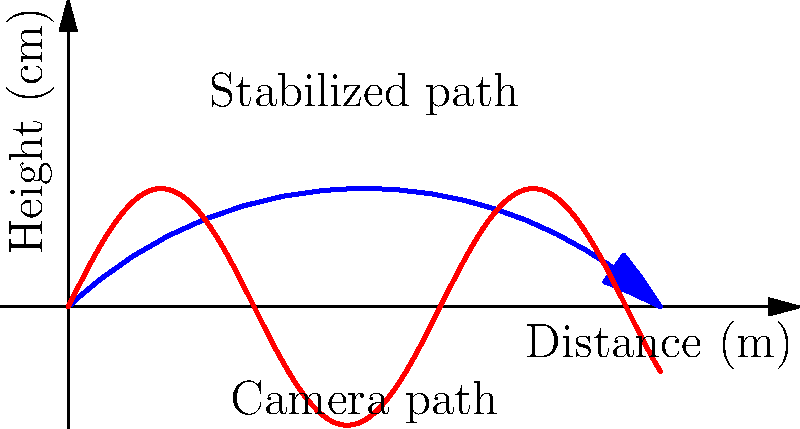In a scene for an upcoming indie film, you're analyzing the use of a steady-cam for a complex tracking shot. The camera moves along a curved path for 10 meters, with vertical variations of up to 20 cm. If the steady-cam system can compensate for 90% of the vertical movement, what is the maximum vertical deviation the viewers will perceive in the final shot? To solve this problem, let's break it down step-by-step:

1. Understand the given information:
   - The camera moves along a curved path for 10 meters
   - The vertical variations are up to 20 cm
   - The steady-cam system compensates for 90% of the vertical movement

2. Calculate the uncompensated movement:
   - If 90% is compensated, then 10% of the movement remains uncompensated
   - Uncompensated percentage = 100% - 90% = 10%

3. Calculate the maximum vertical deviation perceived by viewers:
   - Maximum vertical variation = 20 cm
   - Uncompensated movement = 10% of 20 cm
   - Uncompensated movement = 0.10 × 20 cm = 2 cm

Therefore, the maximum vertical deviation that viewers will perceive in the final shot is 2 cm.

This analysis demonstrates how steady-cam technology significantly reduces camera shake and improves the smoothness of tracking shots, which is crucial for maintaining the cinematic quality in indie and regional films.
Answer: 2 cm 